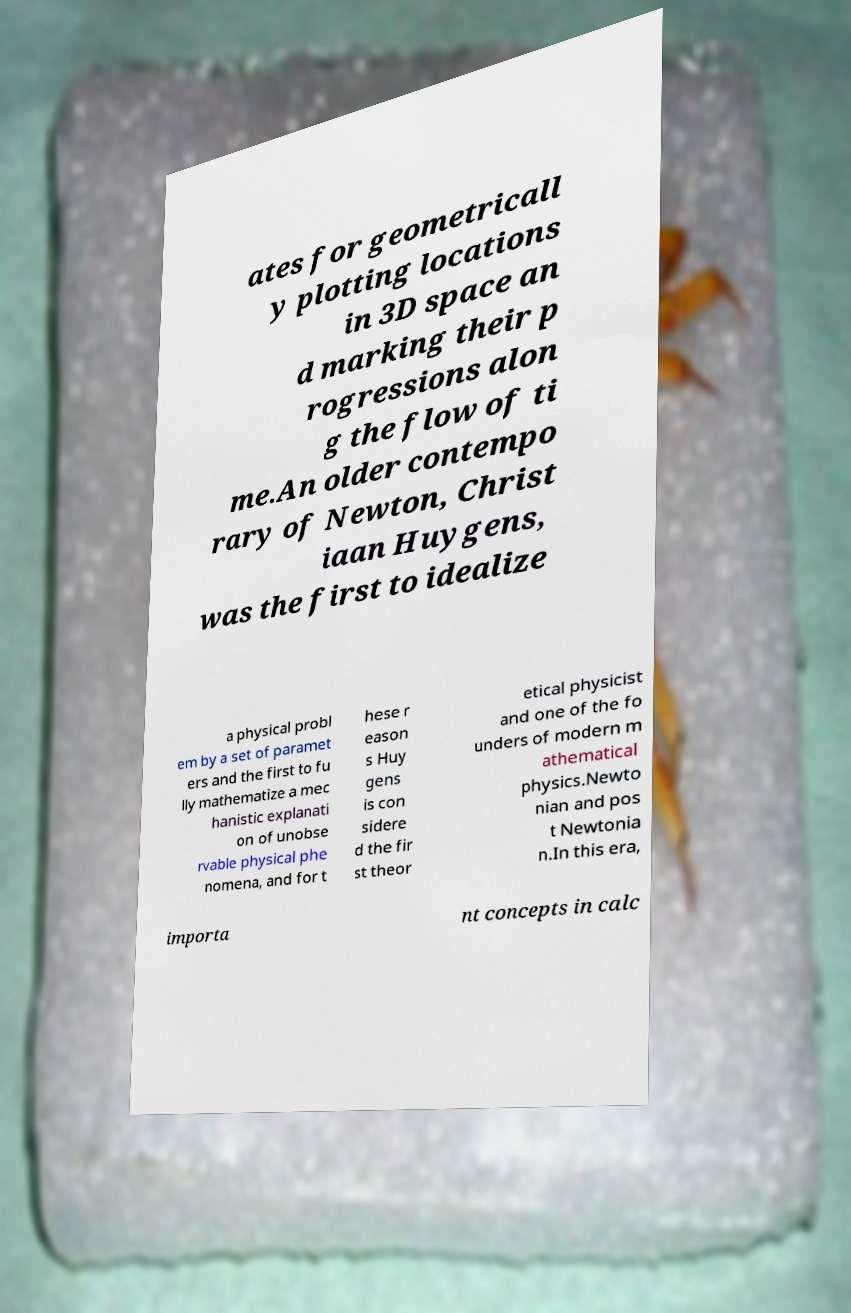Can you accurately transcribe the text from the provided image for me? ates for geometricall y plotting locations in 3D space an d marking their p rogressions alon g the flow of ti me.An older contempo rary of Newton, Christ iaan Huygens, was the first to idealize a physical probl em by a set of paramet ers and the first to fu lly mathematize a mec hanistic explanati on of unobse rvable physical phe nomena, and for t hese r eason s Huy gens is con sidere d the fir st theor etical physicist and one of the fo unders of modern m athematical physics.Newto nian and pos t Newtonia n.In this era, importa nt concepts in calc 